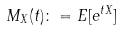<formula> <loc_0><loc_0><loc_500><loc_500>M _ { X } ( t ) \colon = E [ e ^ { t X } ]</formula> 